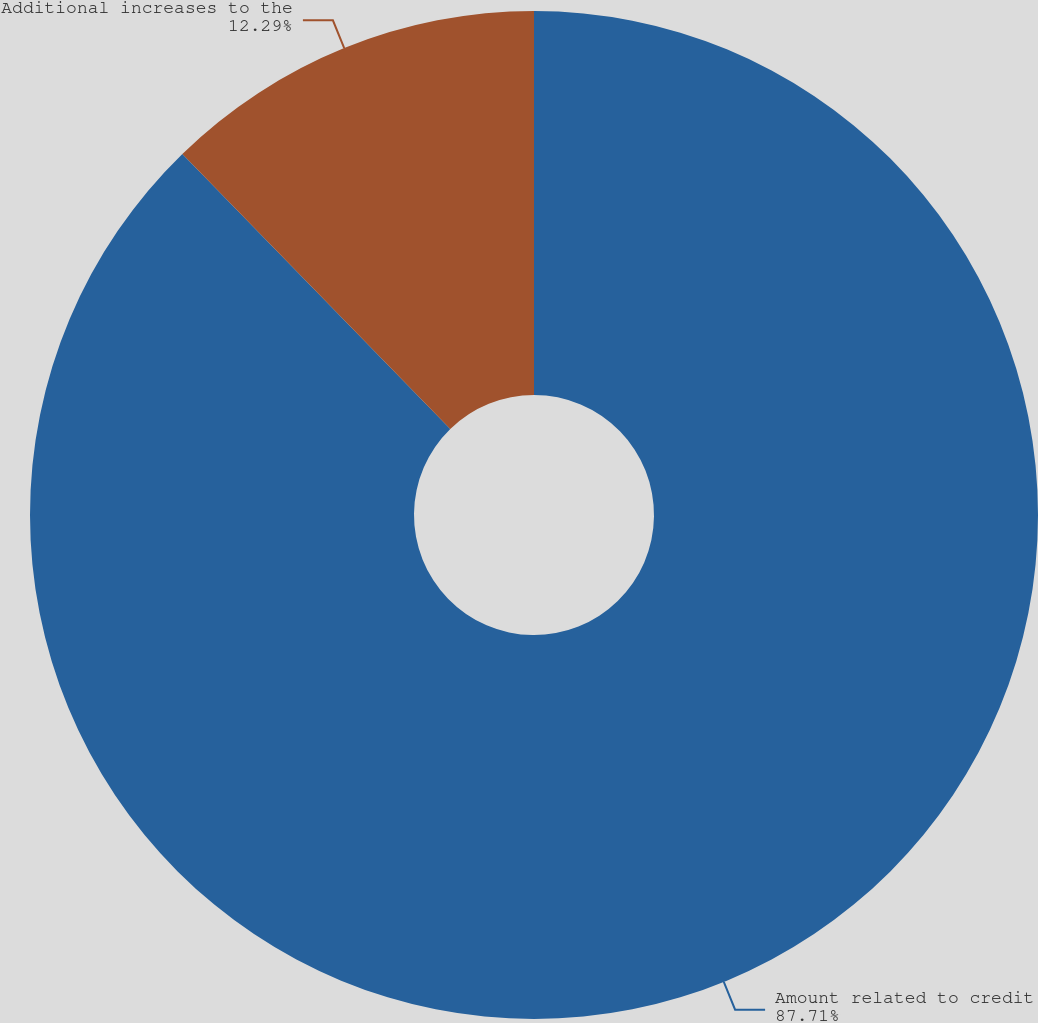Convert chart. <chart><loc_0><loc_0><loc_500><loc_500><pie_chart><fcel>Amount related to credit<fcel>Additional increases to the<nl><fcel>87.71%<fcel>12.29%<nl></chart> 